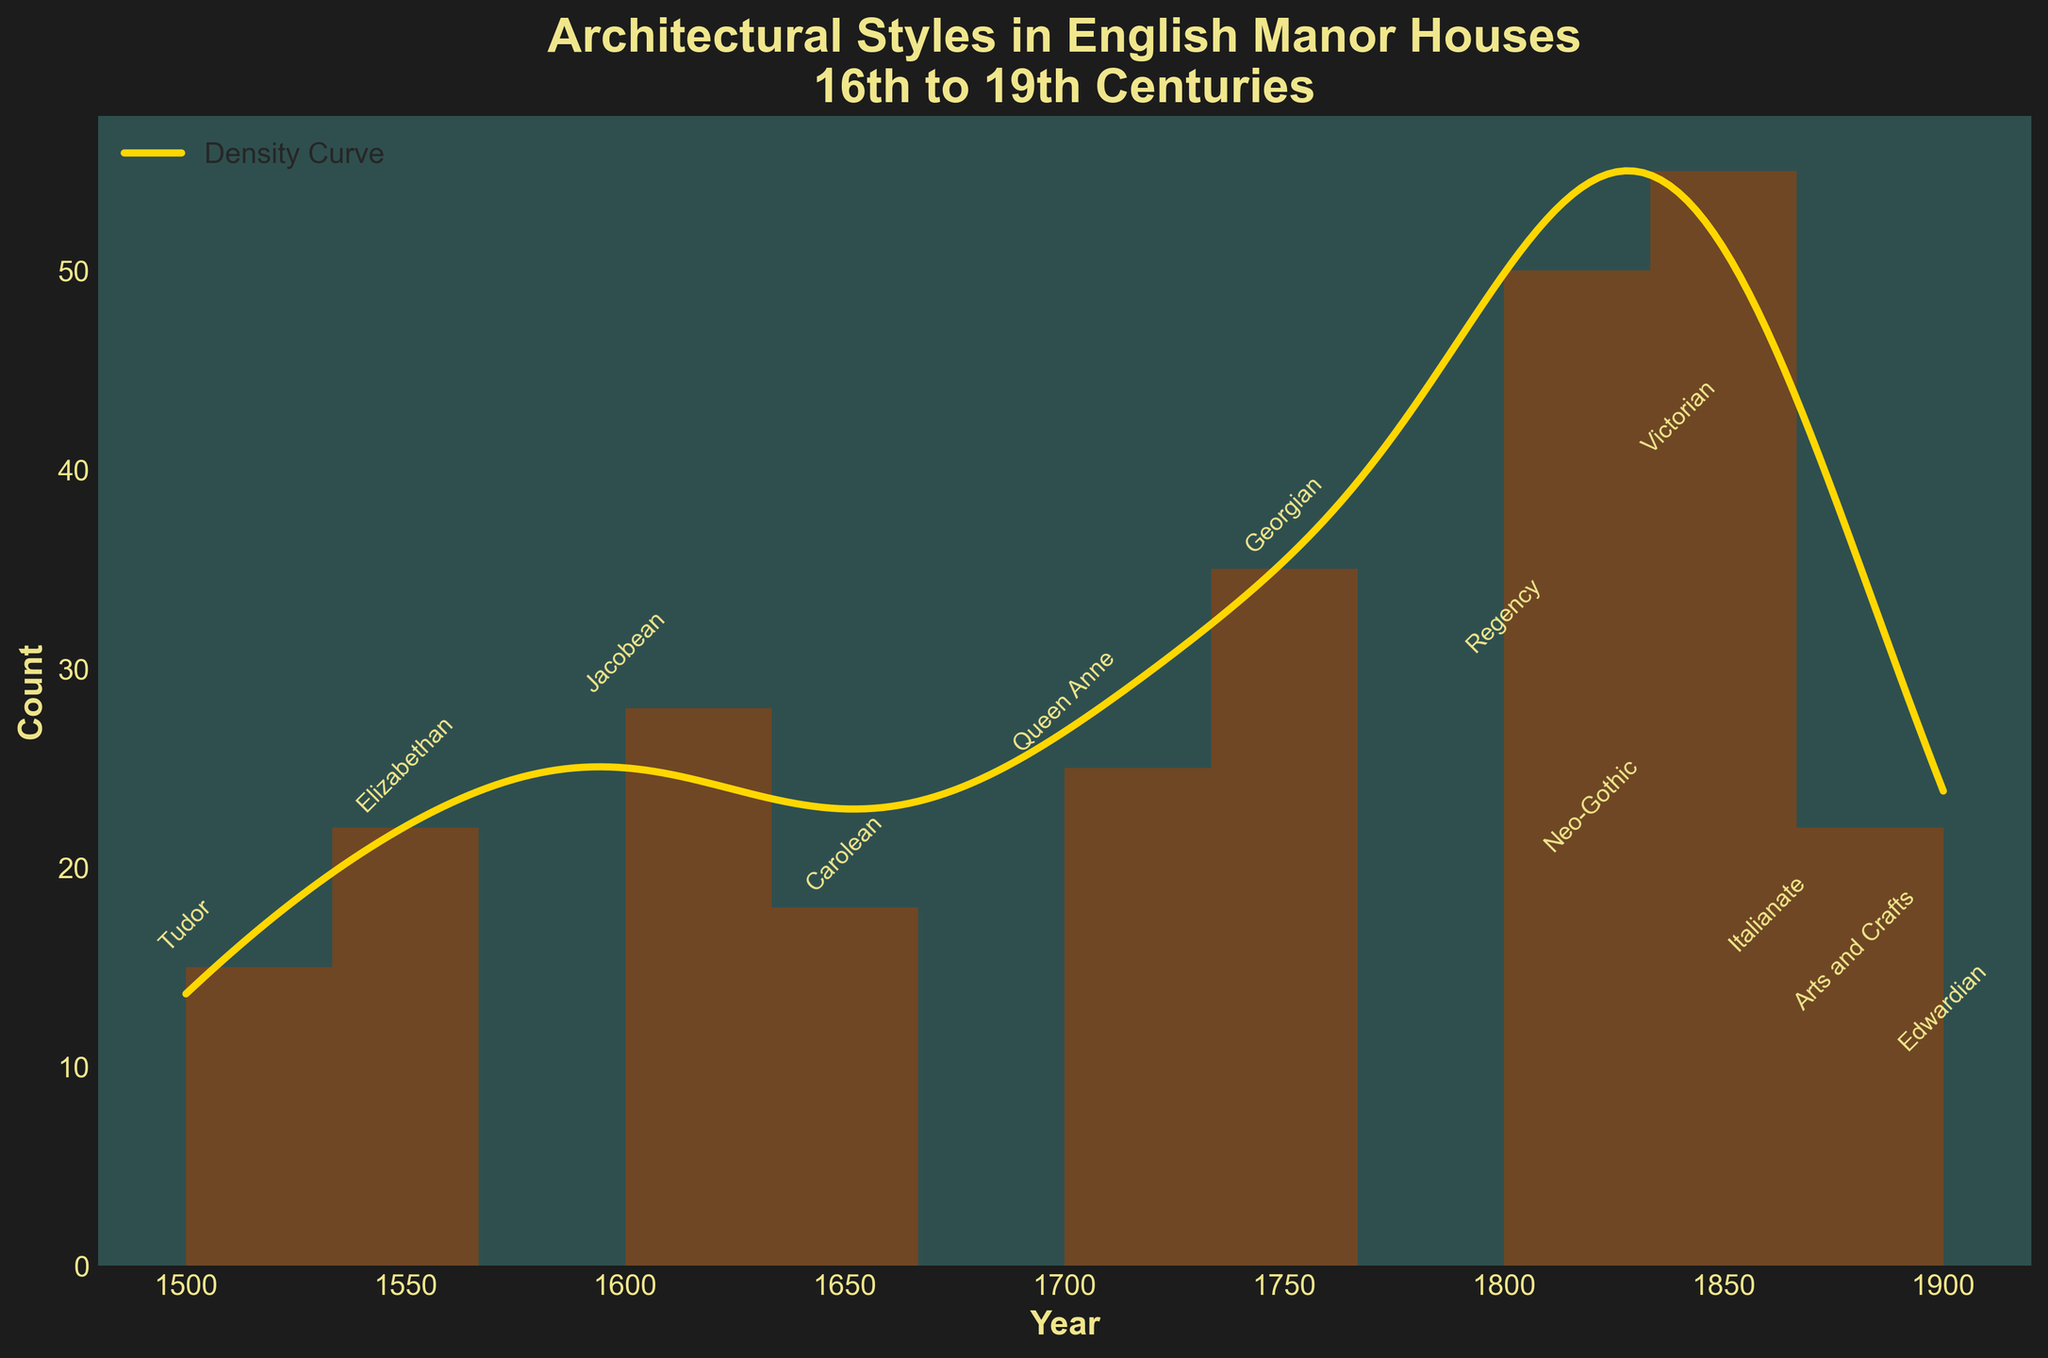What is the title of the plot? The title of the plot can be found at the top and typically provides a summary of what the plot is about. In this case, it indicates the timeline distribution of architectural styles in English manor houses over several centuries.
Answer: Architectural Styles in English Manor Houses 16th to 19th Centuries What does the x-axis represent? The x-axis, usually found at the bottom of the plot, shows the range of years being examined in this plot.
Answer: Year What is the highest peak on the density curve? Observing the density curve, the highest peak corresponds to the era that had the most significant density in constructing manor houses. This can be identified by locating the maximum value on the smooth density line.
Answer: Around the year 1840 Which architectural style had the highest count around the year 1840? By looking at the histogram bars and the annotations, you can identify which style had the highest count around this year, which corresponds to the tallest bar near 1840.
Answer: Victorian Between which years does the chart show data? The chart's x-axis labels the range of years being analyzed. By looking at the first and last tick marks, we can see the full span of years covered.
Answer: 1500 to 1900 Which two styles have the lowest counts, and what are their counts? By looking at the heights of the bars and their annotations, the two shortest bars indicate the styles with the lowest counts.
Answer: Edwardian and Arts and Crafts; 10 and 12 How does the count of Georgian style compare to the count of Regency style? To determine this, compare the heights of the bars corresponding to Georgian and Regency styles. The one with a higher bar has a greater count.
Answer: Georgian is higher than Regency; 35 vs. 30 What is the general trend in manor house counts from the 16th to 19th centuries? To identify the trend, observe the shape of the density curve and the pattern in the histogram bars from left to right, indicating an overall increase or decrease in counts.
Answer: Generally increasing until the 19th century, then decreasing Around which year does the histogram show a decrease in counts for the first time? Identify the first noticeable drop in the heights of the histogram bars when moving from left to right along the x-axis.
Answer: Around the year 1650 What does the density curve (KDE) represent in this plot? The density curve shows the estimated probability density function of the data, providing a smooth representation of where most of the manor houses were built over time.
Answer: Estimated density of manor house counts over time 